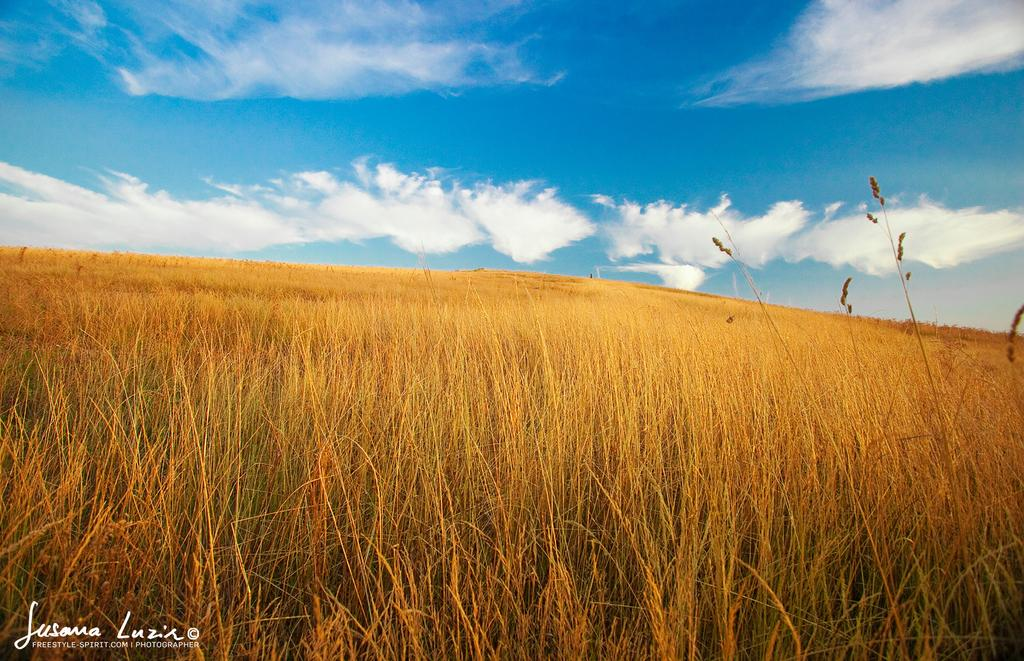What can be found in the bottom left corner of the image? There is a watermark on the bottom left of the image. What type of vegetation is visible on the ground in the background? Dry grass is present on the ground in the background. How would you describe the sky in the image? The sky is blue and has clouds in the background. What type of drain is visible in the image? There is no drain present in the image. What type of pleasure can be seen being experienced by the clouds in the image? The clouds in the image are not experiencing any pleasure, as they are inanimate objects. 